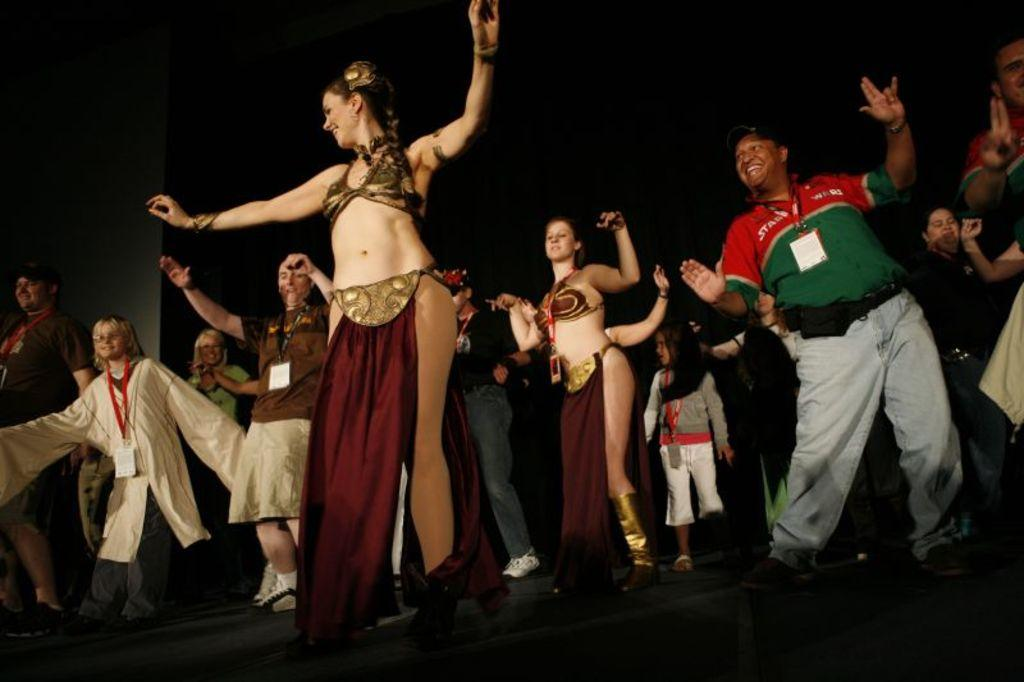How many persons are in the image? There are persons in the image. What can be observed about the dresses worn by the persons? The persons are wearing different color dresses. What activity are the persons engaged in? The persons are dancing on a stage. What is the color of the background in the image? The background of the image is dark in color. How does the heart rate of the persons increase during the dance performance in the image? There is no information about the heart rates of the persons in the image, so it cannot be determined how their heart rates might increase during the dance performance. 